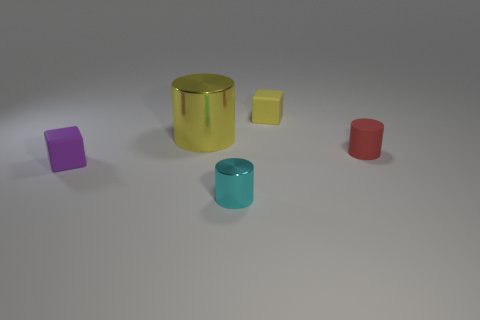There is a big shiny object; is its color the same as the block that is in front of the large metal cylinder?
Offer a terse response. No. Is there a small brown rubber thing of the same shape as the red matte object?
Keep it short and to the point. No. How many objects are either tiny red metal things or small rubber things right of the yellow rubber cube?
Offer a terse response. 1. What number of other things are the same material as the red cylinder?
Your response must be concise. 2. How many things are either purple rubber cubes or large yellow shiny things?
Keep it short and to the point. 2. Is the number of red things to the left of the red matte cylinder greater than the number of tiny objects behind the yellow block?
Your answer should be very brief. No. Is the color of the metal thing right of the big yellow cylinder the same as the small rubber cube that is behind the big yellow metallic object?
Give a very brief answer. No. What is the size of the cylinder that is on the right side of the small cylinder that is left of the yellow thing on the right side of the yellow metallic cylinder?
Keep it short and to the point. Small. There is another small object that is the same shape as the tiny shiny object; what color is it?
Provide a succinct answer. Red. Are there more metal cylinders that are behind the yellow matte cube than small matte blocks?
Make the answer very short. No. 